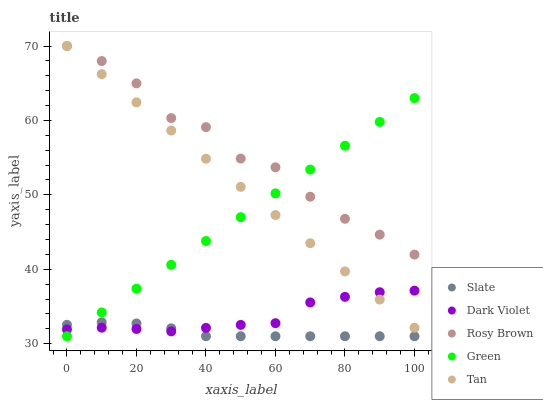Does Slate have the minimum area under the curve?
Answer yes or no. Yes. Does Rosy Brown have the maximum area under the curve?
Answer yes or no. Yes. Does Green have the minimum area under the curve?
Answer yes or no. No. Does Green have the maximum area under the curve?
Answer yes or no. No. Is Green the smoothest?
Answer yes or no. Yes. Is Rosy Brown the roughest?
Answer yes or no. Yes. Is Rosy Brown the smoothest?
Answer yes or no. No. Is Green the roughest?
Answer yes or no. No. Does Slate have the lowest value?
Answer yes or no. Yes. Does Rosy Brown have the lowest value?
Answer yes or no. No. Does Tan have the highest value?
Answer yes or no. Yes. Does Green have the highest value?
Answer yes or no. No. Is Slate less than Rosy Brown?
Answer yes or no. Yes. Is Rosy Brown greater than Slate?
Answer yes or no. Yes. Does Green intersect Rosy Brown?
Answer yes or no. Yes. Is Green less than Rosy Brown?
Answer yes or no. No. Is Green greater than Rosy Brown?
Answer yes or no. No. Does Slate intersect Rosy Brown?
Answer yes or no. No. 